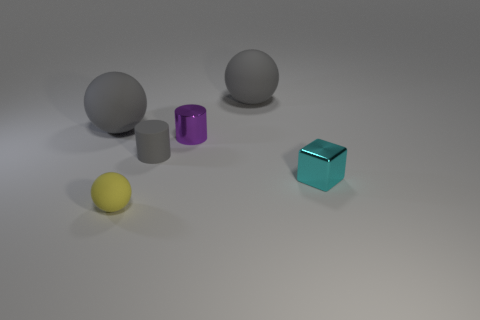Subtract all blocks. How many objects are left? 5 Add 5 rubber things. How many rubber things exist? 9 Add 4 tiny yellow matte objects. How many objects exist? 10 Subtract all yellow balls. How many balls are left? 2 Subtract all gray balls. How many balls are left? 1 Subtract 0 green cylinders. How many objects are left? 6 Subtract all gray cylinders. Subtract all red balls. How many cylinders are left? 1 Subtract all blue cylinders. How many red balls are left? 0 Subtract all small cyan objects. Subtract all small red rubber blocks. How many objects are left? 5 Add 1 small cylinders. How many small cylinders are left? 3 